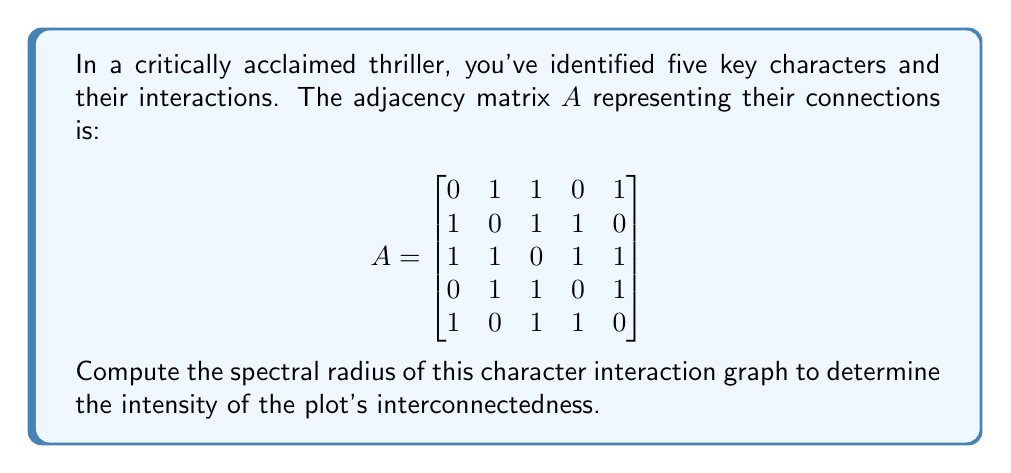Show me your answer to this math problem. To find the spectral radius of the graph, we need to follow these steps:

1) The spectral radius is the largest absolute value of the eigenvalues of the adjacency matrix $A$.

2) To find the eigenvalues, we need to solve the characteristic equation:
   $\det(A - \lambda I) = 0$

3) Expanding this determinant:

   $$\begin{vmatrix}
   -\lambda & 1 & 1 & 0 & 1 \\
   1 & -\lambda & 1 & 1 & 0 \\
   1 & 1 & -\lambda & 1 & 1 \\
   0 & 1 & 1 & -\lambda & 1 \\
   1 & 0 & 1 & 1 & -\lambda
   \end{vmatrix} = 0$$

4) This expands to the characteristic polynomial:
   $\lambda^5 - 10\lambda^3 - 8\lambda^2 + 5\lambda + 4 = 0$

5) Solving this equation numerically (as it's a 5th degree polynomial), we get the eigenvalues:
   $\lambda_1 \approx 2.7321$
   $\lambda_2 \approx -1.7321$
   $\lambda_3 \approx 1.0000$
   $\lambda_4 \approx -1.0000$
   $\lambda_5 \approx 0.0000$

6) The spectral radius is the largest absolute value among these eigenvalues, which is $|\lambda_1| \approx 2.7321$.

7) Interestingly, this value is exactly $1+\sqrt{3}$, which can be verified algebraically.
Answer: $1+\sqrt{3}$ 